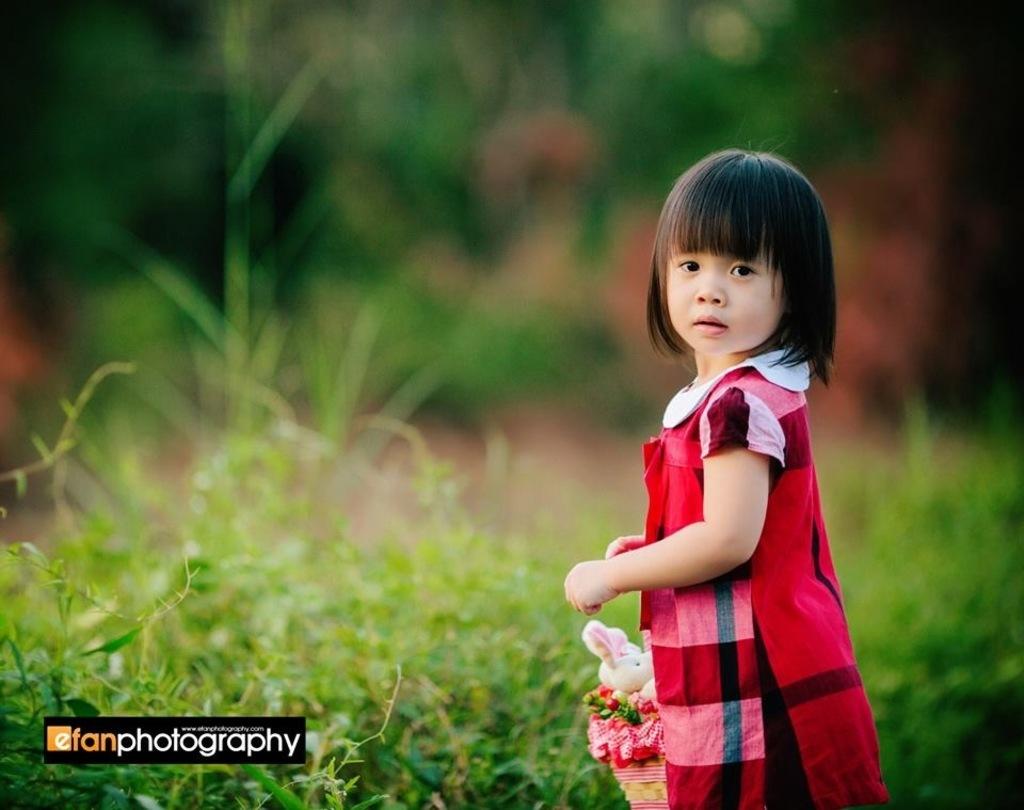"efan" is a brand of what profession?
Your answer should be very brief. Photography. What company owns this image?
Offer a very short reply. Efan photography. 